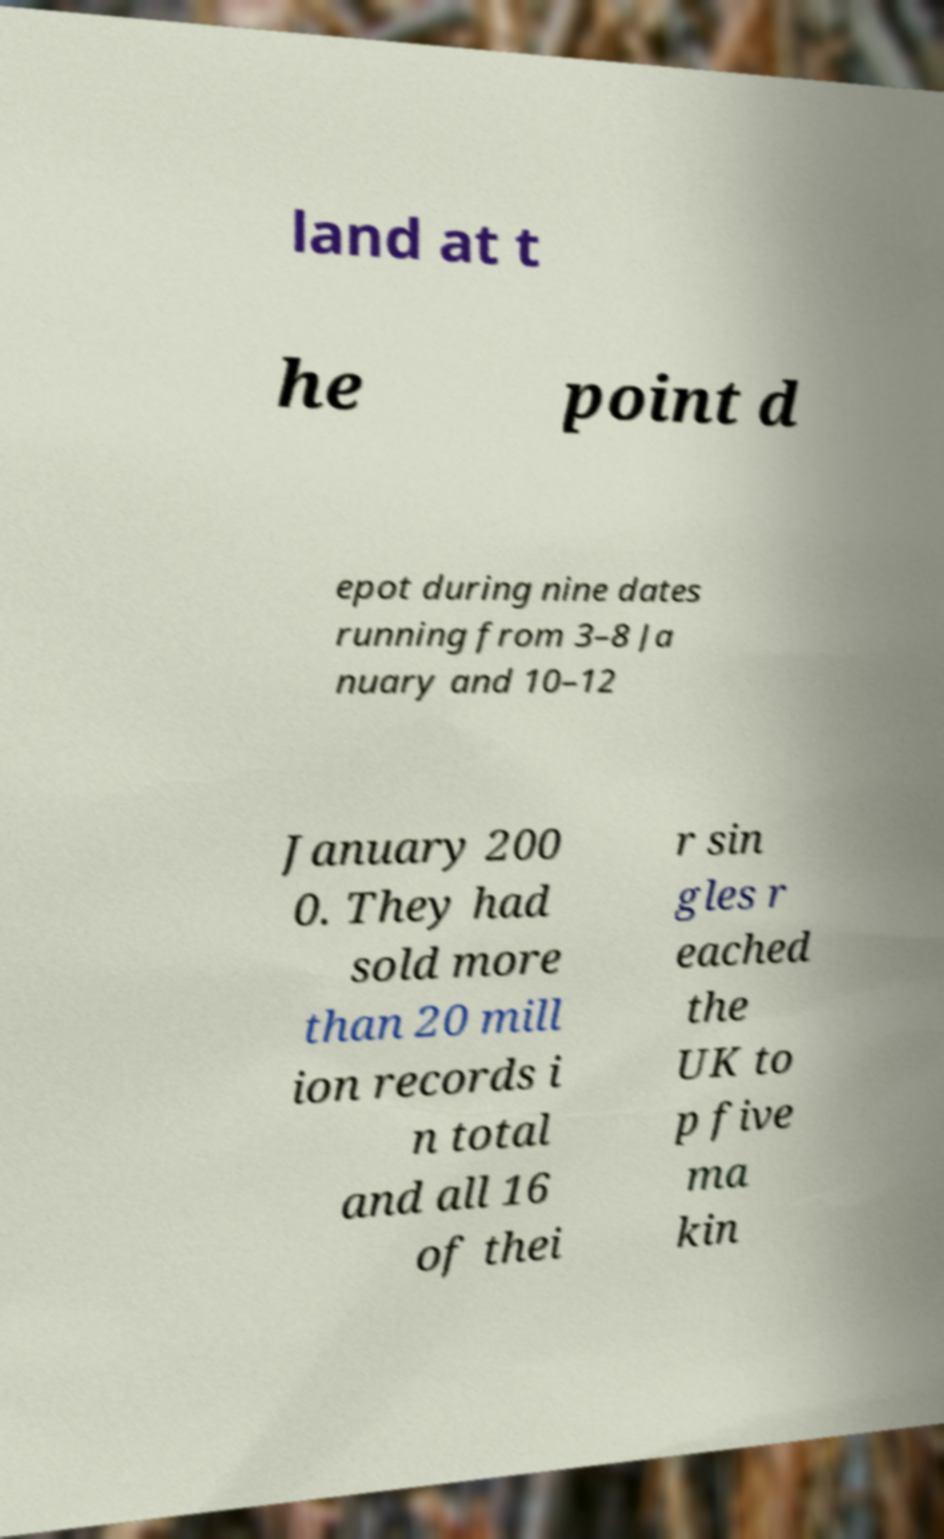Could you assist in decoding the text presented in this image and type it out clearly? land at t he point d epot during nine dates running from 3–8 Ja nuary and 10–12 January 200 0. They had sold more than 20 mill ion records i n total and all 16 of thei r sin gles r eached the UK to p five ma kin 